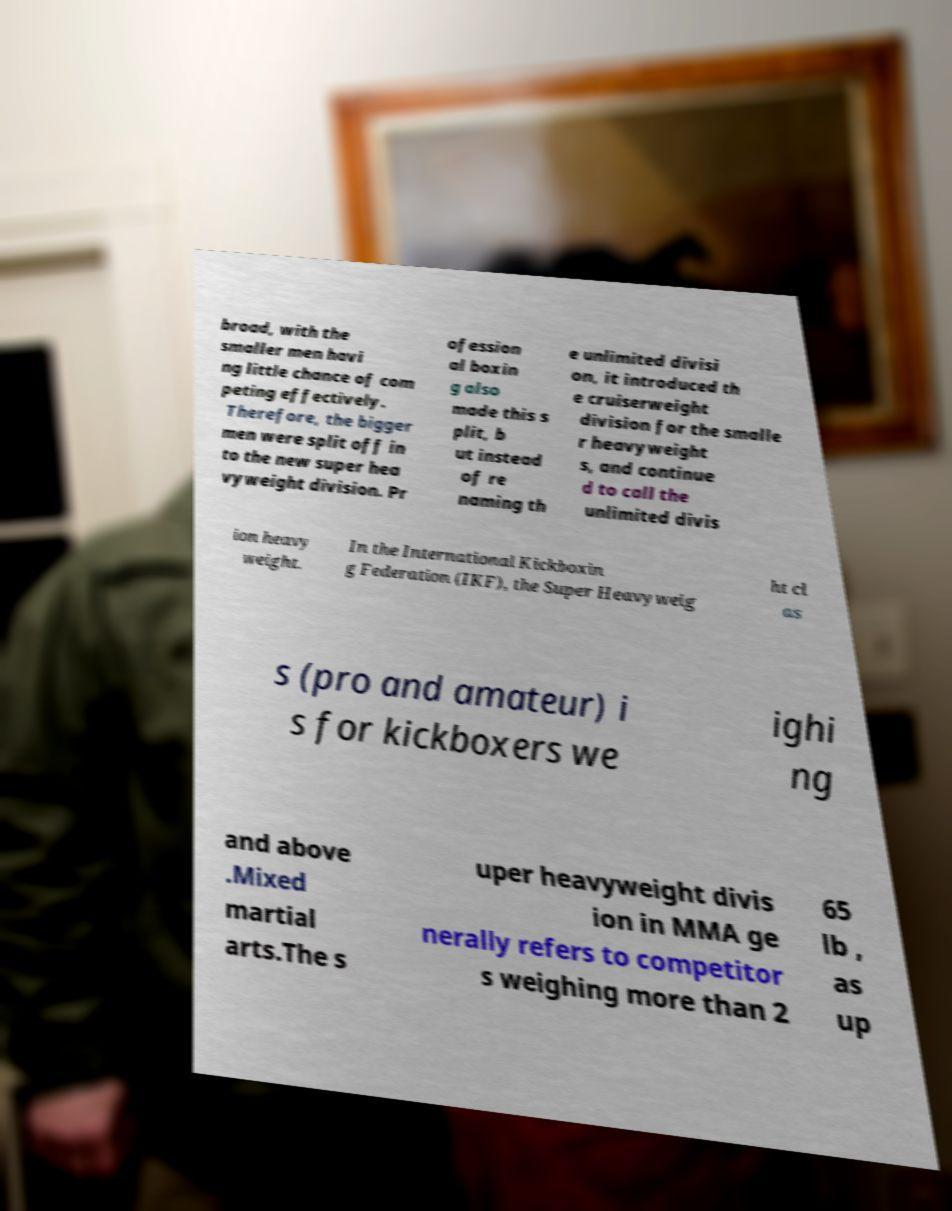What messages or text are displayed in this image? I need them in a readable, typed format. broad, with the smaller men havi ng little chance of com peting effectively. Therefore, the bigger men were split off in to the new super hea vyweight division. Pr ofession al boxin g also made this s plit, b ut instead of re naming th e unlimited divisi on, it introduced th e cruiserweight division for the smalle r heavyweight s, and continue d to call the unlimited divis ion heavy weight. In the International Kickboxin g Federation (IKF), the Super Heavyweig ht cl as s (pro and amateur) i s for kickboxers we ighi ng and above .Mixed martial arts.The s uper heavyweight divis ion in MMA ge nerally refers to competitor s weighing more than 2 65 lb , as up 